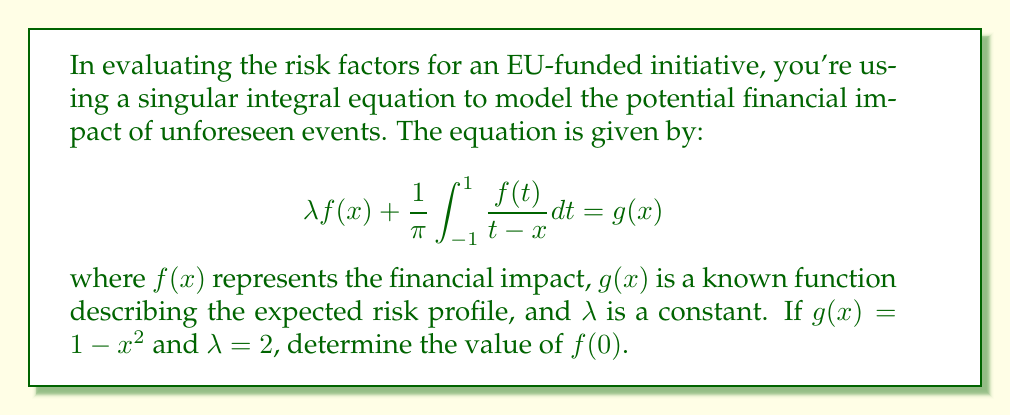What is the answer to this math problem? To solve this problem, we'll follow these steps:

1) For singular integral equations of this form, there's a well-known solution called the Carleman formula. It states that:

   $$f(x) = \frac{C}{\sqrt{1-x^2}} + \frac{1}{\pi\sqrt{1-x^2}} \int_{-1}^{1} \frac{\sqrt{1-t^2}}{t-x} g(t) dt$$

   where $C$ is a constant determined by the value of $\lambda$.

2) For $\lambda = 2$, we know that $C = 0$. This simplifies our solution to:

   $$f(x) = \frac{1}{\pi\sqrt{1-x^2}} \int_{-1}^{1} \frac{\sqrt{1-t^2}}{t-x} g(t) dt$$

3) We're asked to find $f(0)$, so we'll substitute $x=0$:

   $$f(0) = \frac{1}{\pi} \int_{-1}^{1} \frac{\sqrt{1-t^2}}{t} g(t) dt$$

4) Now, we substitute $g(t) = 1 - t^2$:

   $$f(0) = \frac{1}{\pi} \int_{-1}^{1} \frac{\sqrt{1-t^2}}{t} (1 - t^2) dt$$

5) This integral can be simplified:

   $$f(0) = \frac{1}{\pi} \int_{-1}^{1} \frac{\sqrt{1-t^2}}{t} dt - \frac{1}{\pi} \int_{-1}^{1} t\sqrt{1-t^2} dt$$

6) The first integral is an odd function integrated over a symmetric interval, so it equals zero. The second integral can be solved using substitution $u = 1-t^2$:

   $$f(0) = 0 - \frac{1}{\pi} \left[-\frac{1}{3}(1-t^2)^{3/2}\right]_{-1}^{1} = \frac{2}{3\pi}$$

Therefore, the value of $f(0)$ is $\frac{2}{3\pi}$.
Answer: $\frac{2}{3\pi}$ 